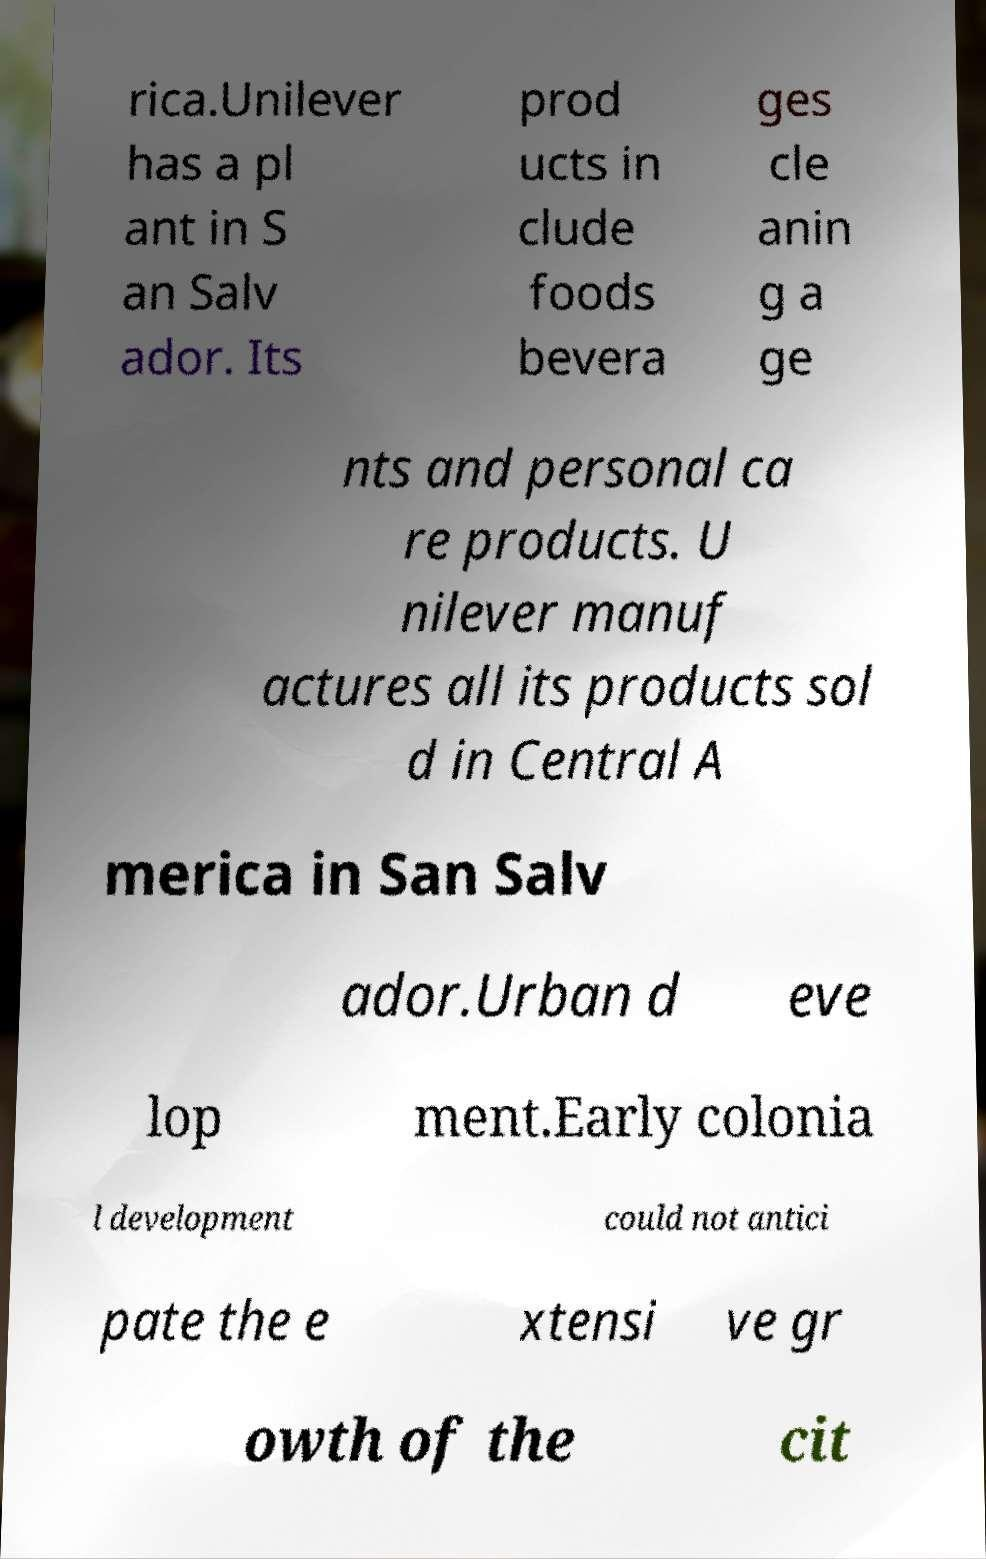For documentation purposes, I need the text within this image transcribed. Could you provide that? rica.Unilever has a pl ant in S an Salv ador. Its prod ucts in clude foods bevera ges cle anin g a ge nts and personal ca re products. U nilever manuf actures all its products sol d in Central A merica in San Salv ador.Urban d eve lop ment.Early colonia l development could not antici pate the e xtensi ve gr owth of the cit 